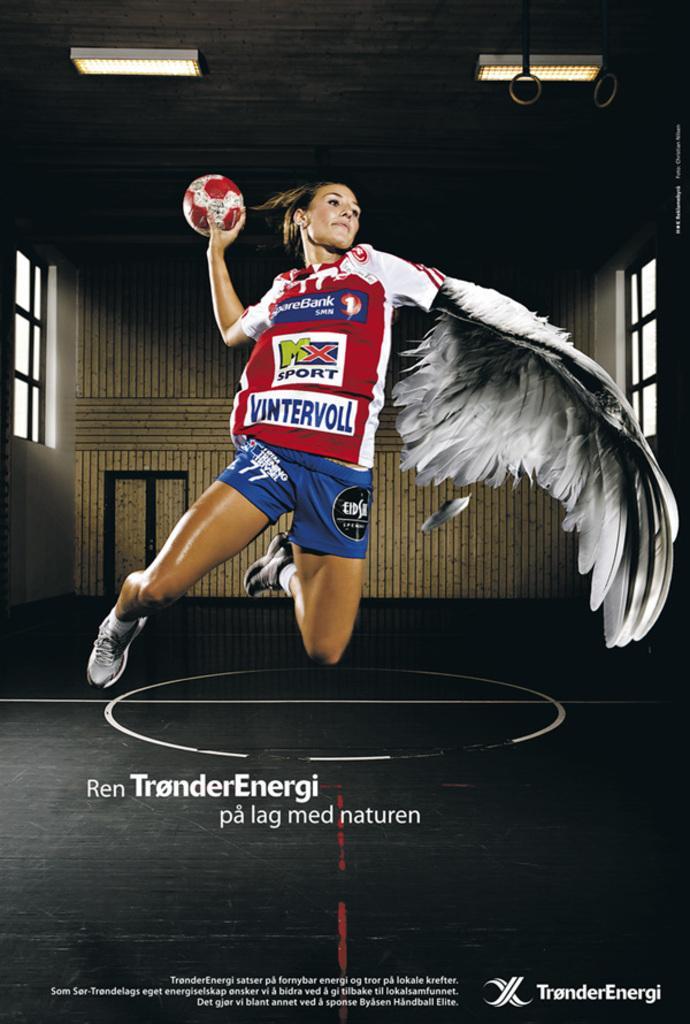How would you summarize this image in a sentence or two? This is an edited image. In this image we can see a girl with a ball in her hand and wing. At the bottom of the image there is text. In the background of the image there is wall. To the both sides of the image there are windows. At the top of the image there is ceiling with lights. 